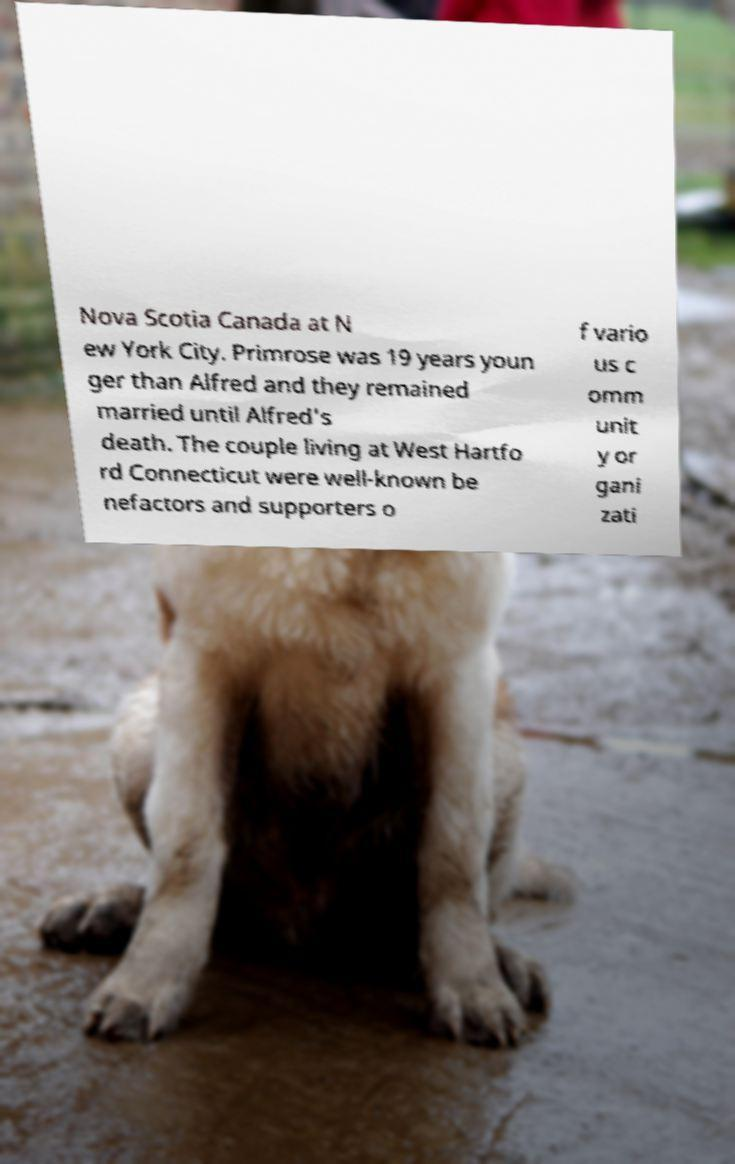Please read and relay the text visible in this image. What does it say? Nova Scotia Canada at N ew York City. Primrose was 19 years youn ger than Alfred and they remained married until Alfred's death. The couple living at West Hartfo rd Connecticut were well-known be nefactors and supporters o f vario us c omm unit y or gani zati 